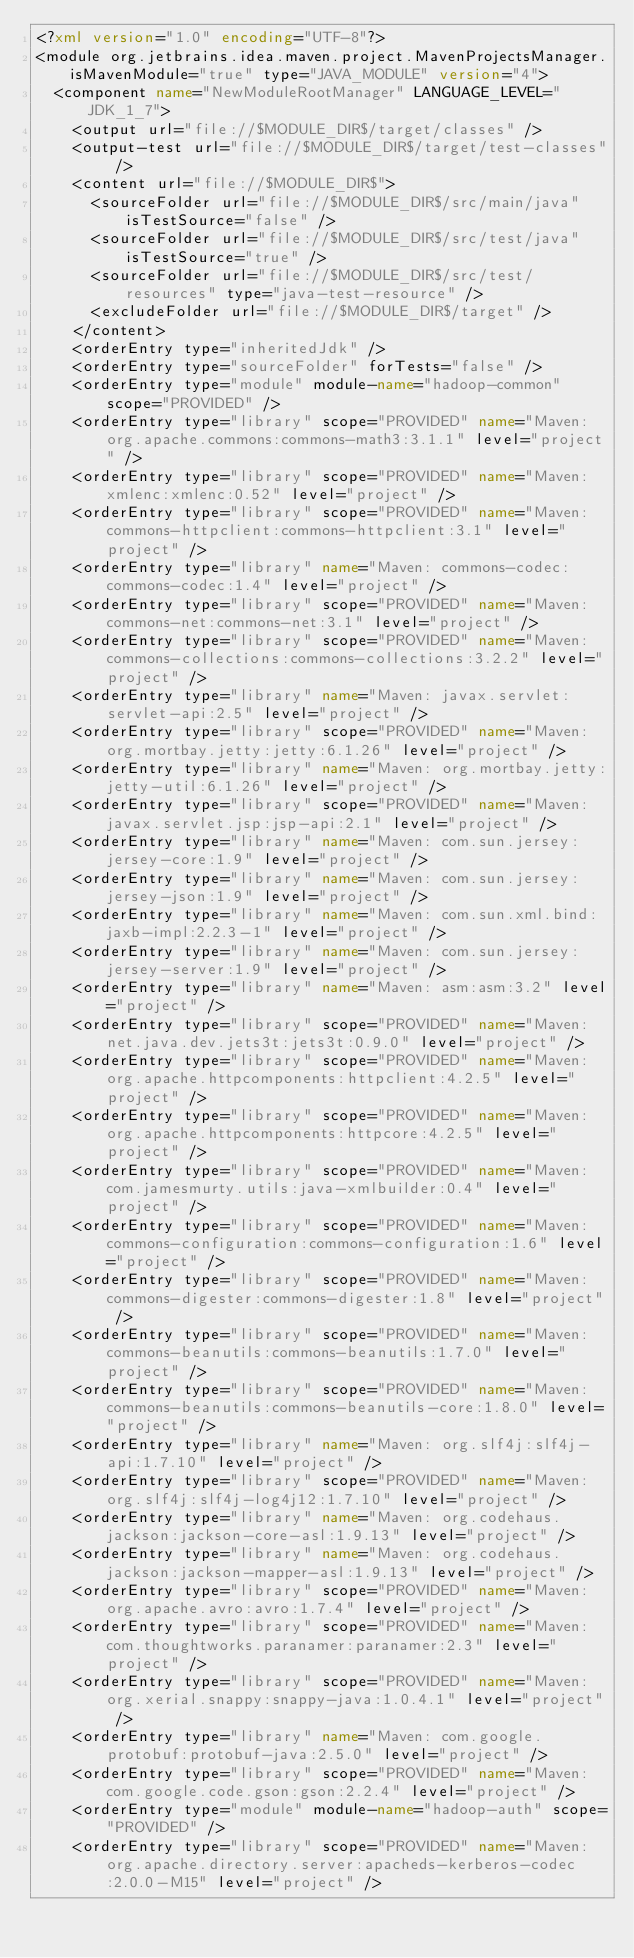Convert code to text. <code><loc_0><loc_0><loc_500><loc_500><_XML_><?xml version="1.0" encoding="UTF-8"?>
<module org.jetbrains.idea.maven.project.MavenProjectsManager.isMavenModule="true" type="JAVA_MODULE" version="4">
  <component name="NewModuleRootManager" LANGUAGE_LEVEL="JDK_1_7">
    <output url="file://$MODULE_DIR$/target/classes" />
    <output-test url="file://$MODULE_DIR$/target/test-classes" />
    <content url="file://$MODULE_DIR$">
      <sourceFolder url="file://$MODULE_DIR$/src/main/java" isTestSource="false" />
      <sourceFolder url="file://$MODULE_DIR$/src/test/java" isTestSource="true" />
      <sourceFolder url="file://$MODULE_DIR$/src/test/resources" type="java-test-resource" />
      <excludeFolder url="file://$MODULE_DIR$/target" />
    </content>
    <orderEntry type="inheritedJdk" />
    <orderEntry type="sourceFolder" forTests="false" />
    <orderEntry type="module" module-name="hadoop-common" scope="PROVIDED" />
    <orderEntry type="library" scope="PROVIDED" name="Maven: org.apache.commons:commons-math3:3.1.1" level="project" />
    <orderEntry type="library" scope="PROVIDED" name="Maven: xmlenc:xmlenc:0.52" level="project" />
    <orderEntry type="library" scope="PROVIDED" name="Maven: commons-httpclient:commons-httpclient:3.1" level="project" />
    <orderEntry type="library" name="Maven: commons-codec:commons-codec:1.4" level="project" />
    <orderEntry type="library" scope="PROVIDED" name="Maven: commons-net:commons-net:3.1" level="project" />
    <orderEntry type="library" scope="PROVIDED" name="Maven: commons-collections:commons-collections:3.2.2" level="project" />
    <orderEntry type="library" name="Maven: javax.servlet:servlet-api:2.5" level="project" />
    <orderEntry type="library" scope="PROVIDED" name="Maven: org.mortbay.jetty:jetty:6.1.26" level="project" />
    <orderEntry type="library" name="Maven: org.mortbay.jetty:jetty-util:6.1.26" level="project" />
    <orderEntry type="library" scope="PROVIDED" name="Maven: javax.servlet.jsp:jsp-api:2.1" level="project" />
    <orderEntry type="library" name="Maven: com.sun.jersey:jersey-core:1.9" level="project" />
    <orderEntry type="library" name="Maven: com.sun.jersey:jersey-json:1.9" level="project" />
    <orderEntry type="library" name="Maven: com.sun.xml.bind:jaxb-impl:2.2.3-1" level="project" />
    <orderEntry type="library" name="Maven: com.sun.jersey:jersey-server:1.9" level="project" />
    <orderEntry type="library" name="Maven: asm:asm:3.2" level="project" />
    <orderEntry type="library" scope="PROVIDED" name="Maven: net.java.dev.jets3t:jets3t:0.9.0" level="project" />
    <orderEntry type="library" scope="PROVIDED" name="Maven: org.apache.httpcomponents:httpclient:4.2.5" level="project" />
    <orderEntry type="library" scope="PROVIDED" name="Maven: org.apache.httpcomponents:httpcore:4.2.5" level="project" />
    <orderEntry type="library" scope="PROVIDED" name="Maven: com.jamesmurty.utils:java-xmlbuilder:0.4" level="project" />
    <orderEntry type="library" scope="PROVIDED" name="Maven: commons-configuration:commons-configuration:1.6" level="project" />
    <orderEntry type="library" scope="PROVIDED" name="Maven: commons-digester:commons-digester:1.8" level="project" />
    <orderEntry type="library" scope="PROVIDED" name="Maven: commons-beanutils:commons-beanutils:1.7.0" level="project" />
    <orderEntry type="library" scope="PROVIDED" name="Maven: commons-beanutils:commons-beanutils-core:1.8.0" level="project" />
    <orderEntry type="library" name="Maven: org.slf4j:slf4j-api:1.7.10" level="project" />
    <orderEntry type="library" scope="PROVIDED" name="Maven: org.slf4j:slf4j-log4j12:1.7.10" level="project" />
    <orderEntry type="library" name="Maven: org.codehaus.jackson:jackson-core-asl:1.9.13" level="project" />
    <orderEntry type="library" name="Maven: org.codehaus.jackson:jackson-mapper-asl:1.9.13" level="project" />
    <orderEntry type="library" scope="PROVIDED" name="Maven: org.apache.avro:avro:1.7.4" level="project" />
    <orderEntry type="library" scope="PROVIDED" name="Maven: com.thoughtworks.paranamer:paranamer:2.3" level="project" />
    <orderEntry type="library" scope="PROVIDED" name="Maven: org.xerial.snappy:snappy-java:1.0.4.1" level="project" />
    <orderEntry type="library" name="Maven: com.google.protobuf:protobuf-java:2.5.0" level="project" />
    <orderEntry type="library" scope="PROVIDED" name="Maven: com.google.code.gson:gson:2.2.4" level="project" />
    <orderEntry type="module" module-name="hadoop-auth" scope="PROVIDED" />
    <orderEntry type="library" scope="PROVIDED" name="Maven: org.apache.directory.server:apacheds-kerberos-codec:2.0.0-M15" level="project" /></code> 